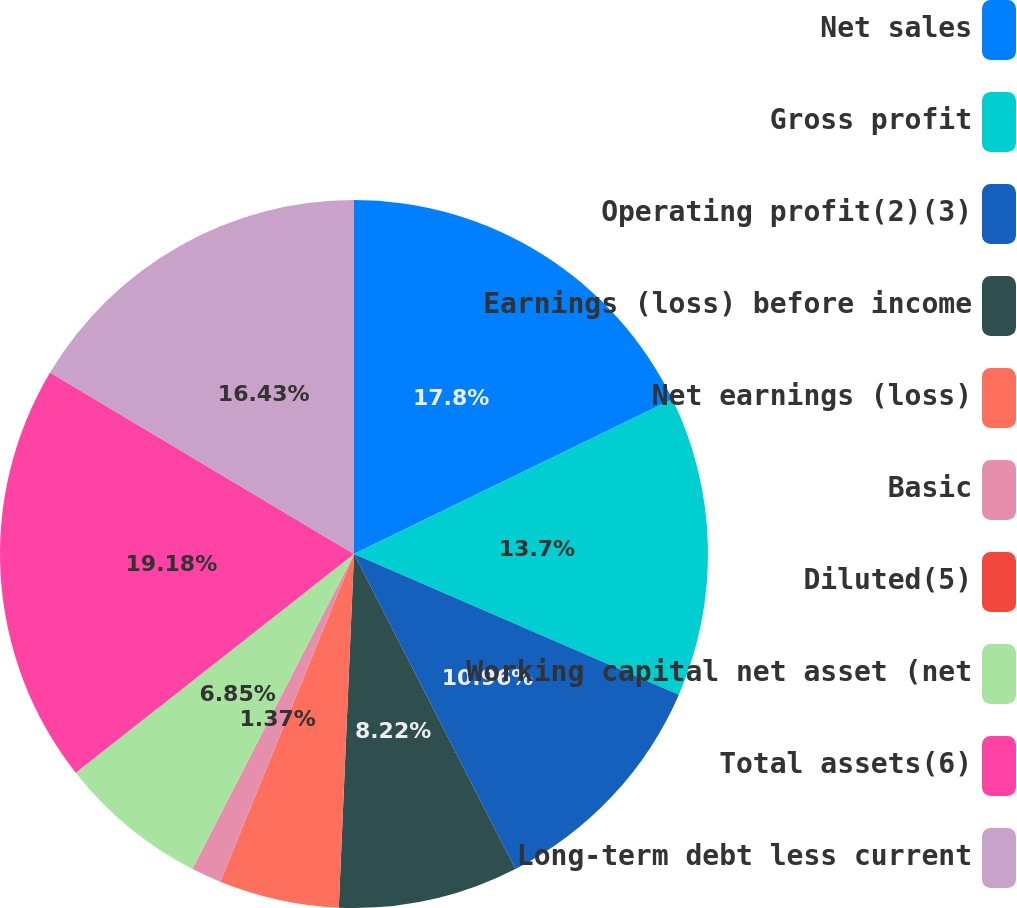<chart> <loc_0><loc_0><loc_500><loc_500><pie_chart><fcel>Net sales<fcel>Gross profit<fcel>Operating profit(2)(3)<fcel>Earnings (loss) before income<fcel>Net earnings (loss)<fcel>Basic<fcel>Diluted(5)<fcel>Working capital net asset (net<fcel>Total assets(6)<fcel>Long-term debt less current<nl><fcel>17.8%<fcel>13.7%<fcel>10.96%<fcel>8.22%<fcel>5.48%<fcel>1.37%<fcel>0.01%<fcel>6.85%<fcel>19.17%<fcel>16.43%<nl></chart> 